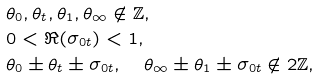<formula> <loc_0><loc_0><loc_500><loc_500>& \theta _ { 0 } , \theta _ { t } , \theta _ { 1 } , \theta _ { \infty } \notin \mathbb { Z } , \\ & 0 < { \Re } ( \sigma _ { 0 t } ) < 1 , \\ & \theta _ { 0 } \pm \theta _ { t } \pm \sigma _ { 0 t } , \quad \theta _ { \infty } \pm \theta _ { 1 } \pm \sigma _ { 0 t } \notin 2 \mathbb { Z } ,</formula> 